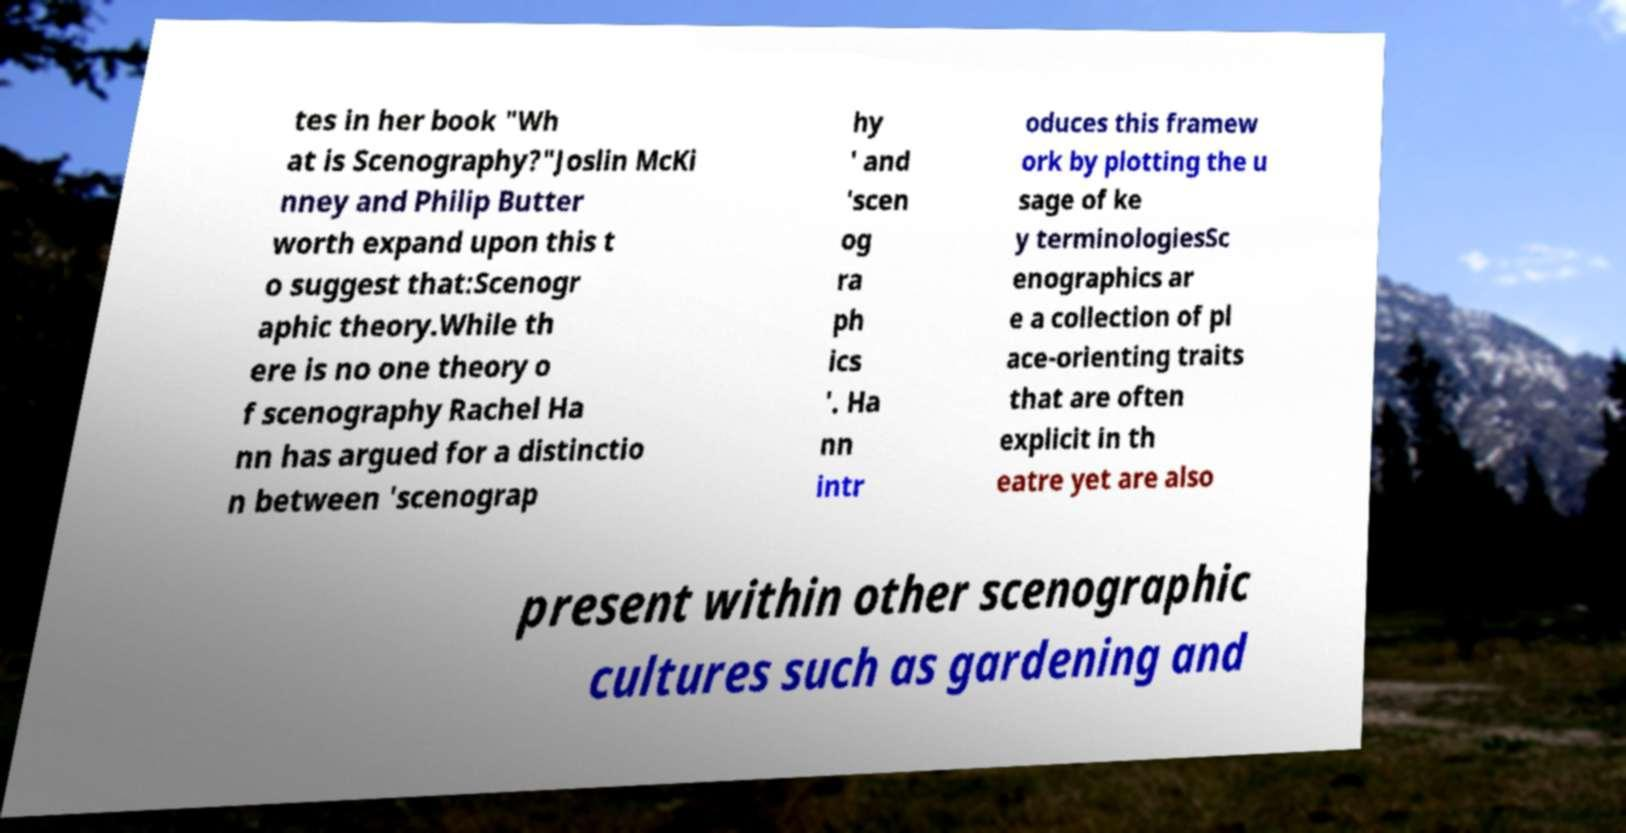Can you accurately transcribe the text from the provided image for me? tes in her book "Wh at is Scenography?"Joslin McKi nney and Philip Butter worth expand upon this t o suggest that:Scenogr aphic theory.While th ere is no one theory o f scenography Rachel Ha nn has argued for a distinctio n between 'scenograp hy ' and 'scen og ra ph ics '. Ha nn intr oduces this framew ork by plotting the u sage of ke y terminologiesSc enographics ar e a collection of pl ace-orienting traits that are often explicit in th eatre yet are also present within other scenographic cultures such as gardening and 